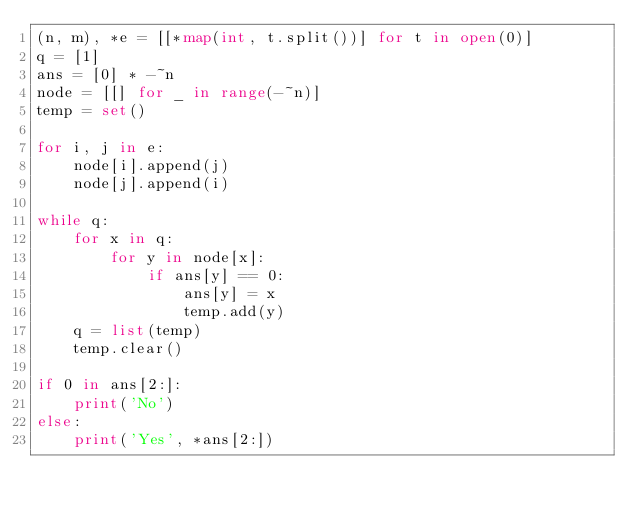Convert code to text. <code><loc_0><loc_0><loc_500><loc_500><_Python_>(n, m), *e = [[*map(int, t.split())] for t in open(0)]
q = [1]
ans = [0] * -~n
node = [[] for _ in range(-~n)]
temp = set()

for i, j in e:
    node[i].append(j)
    node[j].append(i)

while q:
    for x in q:
        for y in node[x]:
            if ans[y] == 0:
                ans[y] = x
                temp.add(y)
    q = list(temp)
    temp.clear()

if 0 in ans[2:]:
    print('No')
else:
    print('Yes', *ans[2:])
</code> 